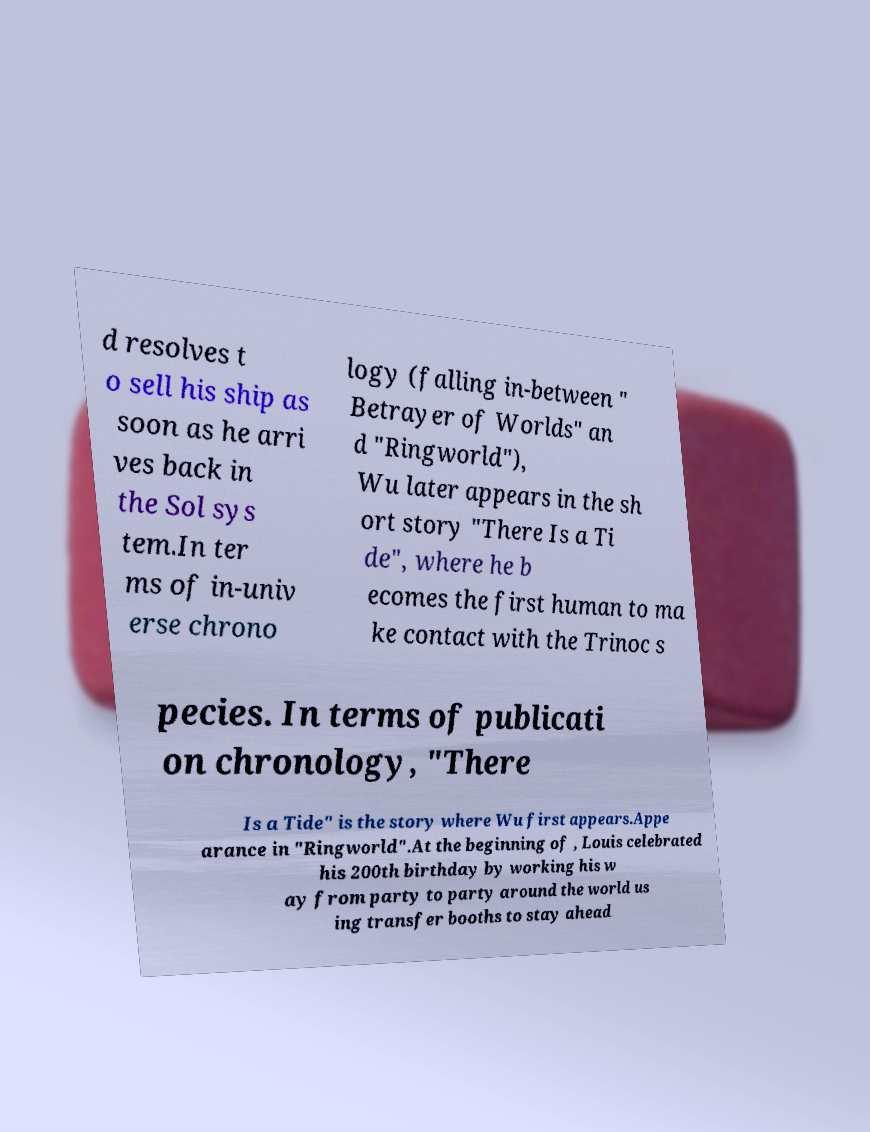Can you read and provide the text displayed in the image?This photo seems to have some interesting text. Can you extract and type it out for me? d resolves t o sell his ship as soon as he arri ves back in the Sol sys tem.In ter ms of in-univ erse chrono logy (falling in-between " Betrayer of Worlds" an d "Ringworld"), Wu later appears in the sh ort story "There Is a Ti de", where he b ecomes the first human to ma ke contact with the Trinoc s pecies. In terms of publicati on chronology, "There Is a Tide" is the story where Wu first appears.Appe arance in "Ringworld".At the beginning of , Louis celebrated his 200th birthday by working his w ay from party to party around the world us ing transfer booths to stay ahead 